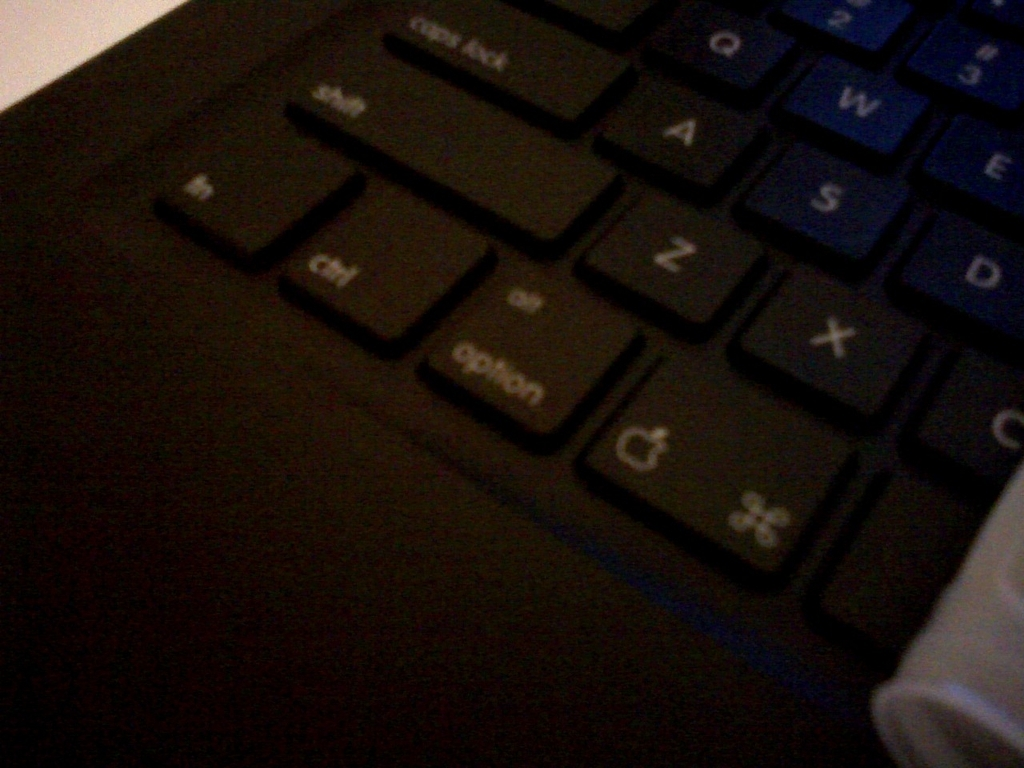Are there any unique features on this keyboard that stand out to you? The keyboard has a distinct backlight, with a gentle blue glow emanating from beneath the keys. This feature can aid typing in low-light conditions and adds an aesthetic element to the device. 